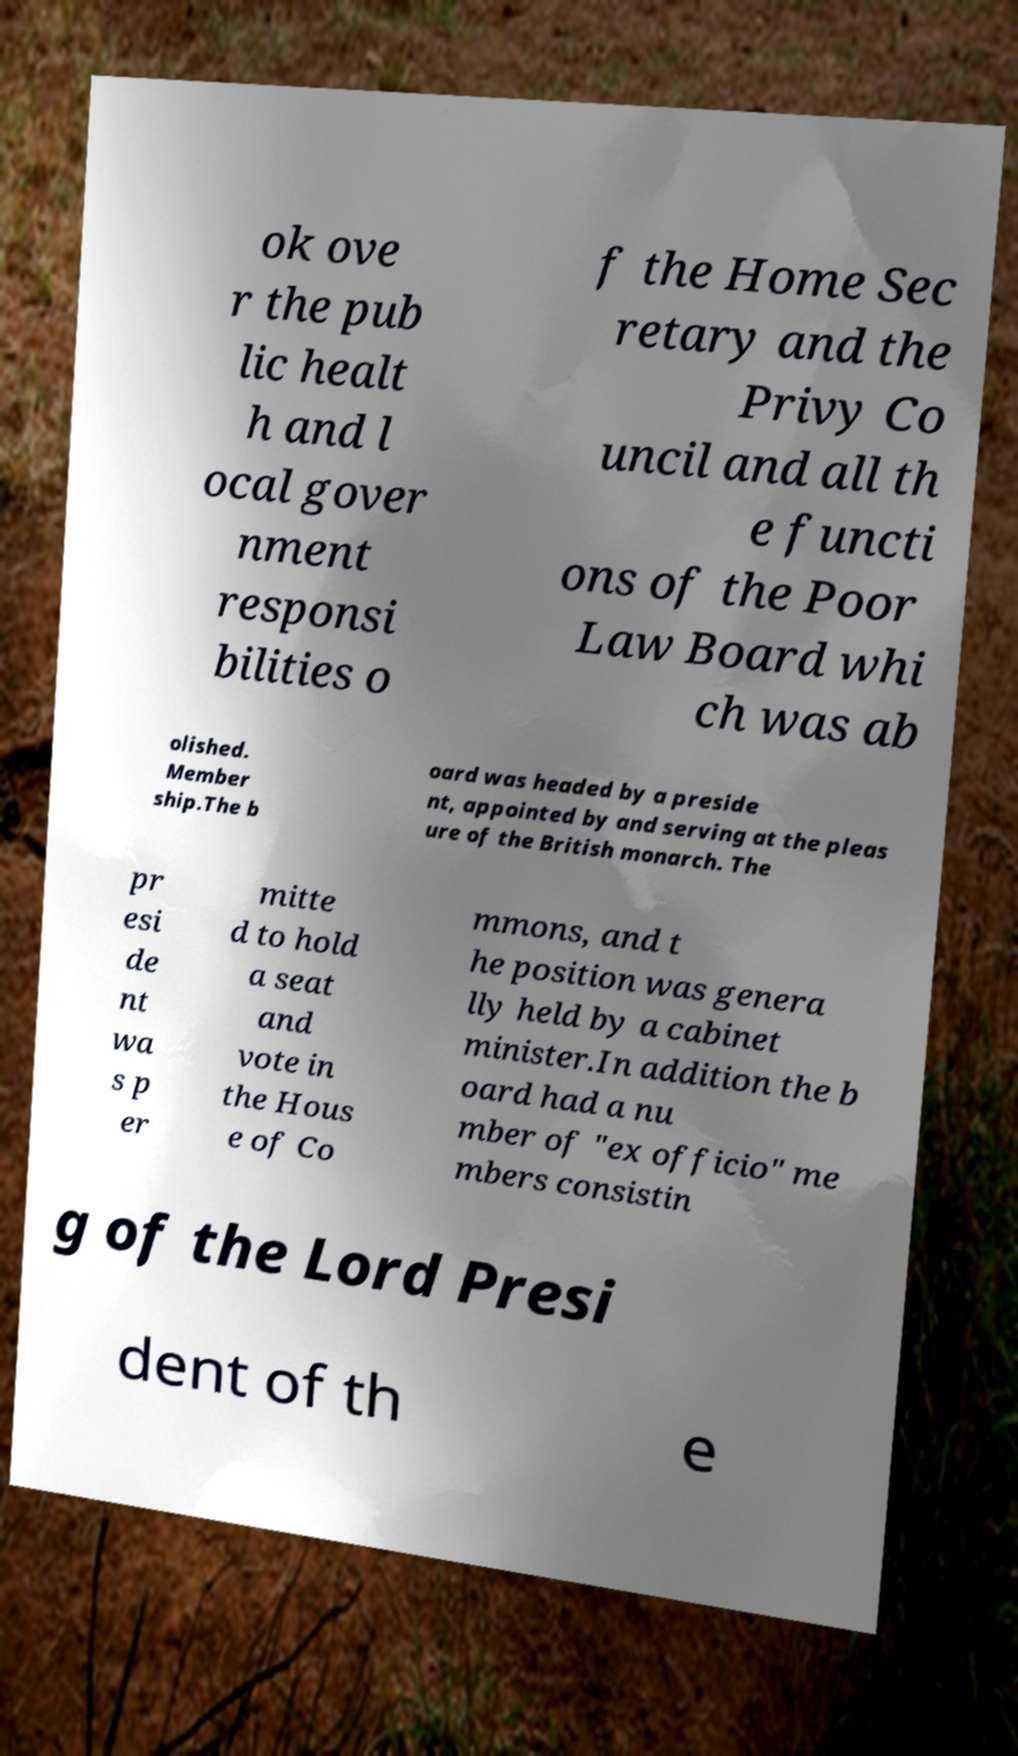Can you accurately transcribe the text from the provided image for me? ok ove r the pub lic healt h and l ocal gover nment responsi bilities o f the Home Sec retary and the Privy Co uncil and all th e functi ons of the Poor Law Board whi ch was ab olished. Member ship.The b oard was headed by a preside nt, appointed by and serving at the pleas ure of the British monarch. The pr esi de nt wa s p er mitte d to hold a seat and vote in the Hous e of Co mmons, and t he position was genera lly held by a cabinet minister.In addition the b oard had a nu mber of "ex officio" me mbers consistin g of the Lord Presi dent of th e 